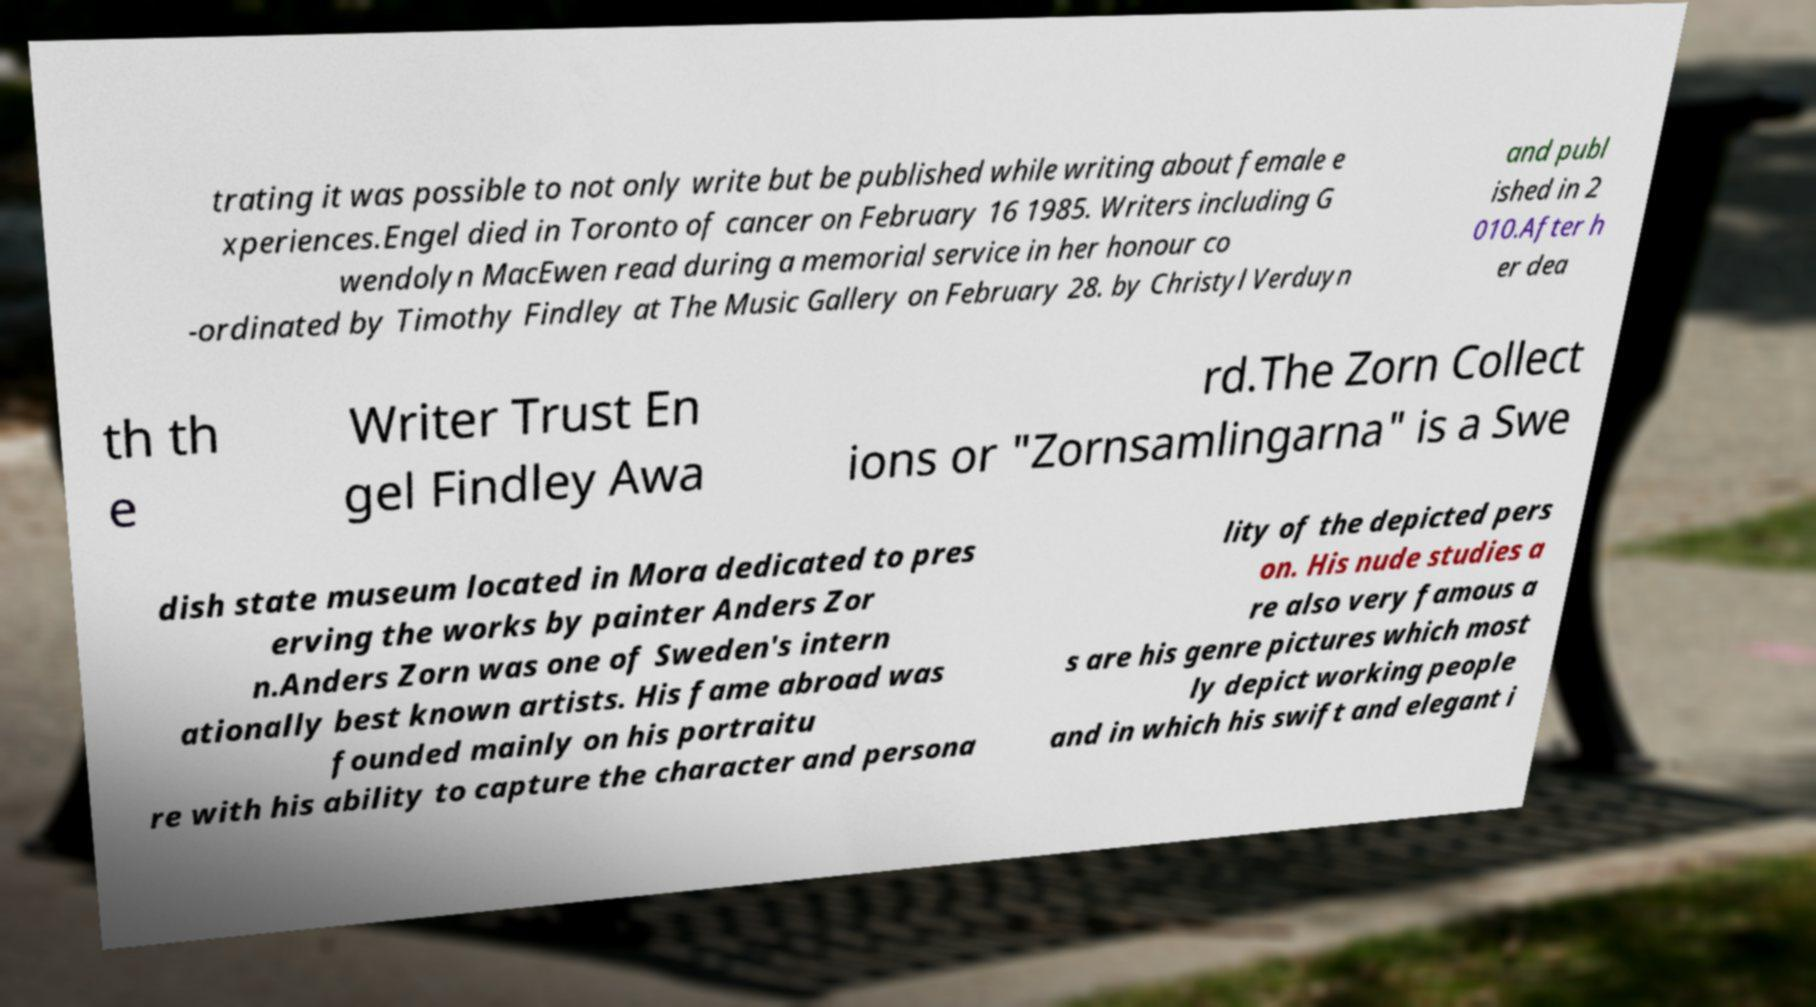Can you read and provide the text displayed in the image?This photo seems to have some interesting text. Can you extract and type it out for me? trating it was possible to not only write but be published while writing about female e xperiences.Engel died in Toronto of cancer on February 16 1985. Writers including G wendolyn MacEwen read during a memorial service in her honour co -ordinated by Timothy Findley at The Music Gallery on February 28. by Christyl Verduyn and publ ished in 2 010.After h er dea th th e Writer Trust En gel Findley Awa rd.The Zorn Collect ions or "Zornsamlingarna" is a Swe dish state museum located in Mora dedicated to pres erving the works by painter Anders Zor n.Anders Zorn was one of Sweden's intern ationally best known artists. His fame abroad was founded mainly on his portraitu re with his ability to capture the character and persona lity of the depicted pers on. His nude studies a re also very famous a s are his genre pictures which most ly depict working people and in which his swift and elegant i 